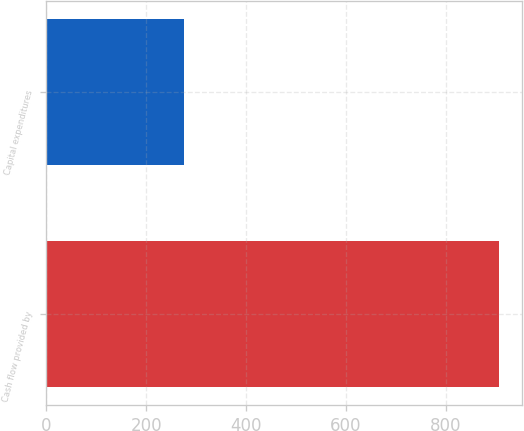<chart> <loc_0><loc_0><loc_500><loc_500><bar_chart><fcel>Cash flow provided by<fcel>Capital expenditures<nl><fcel>906.9<fcel>275.7<nl></chart> 